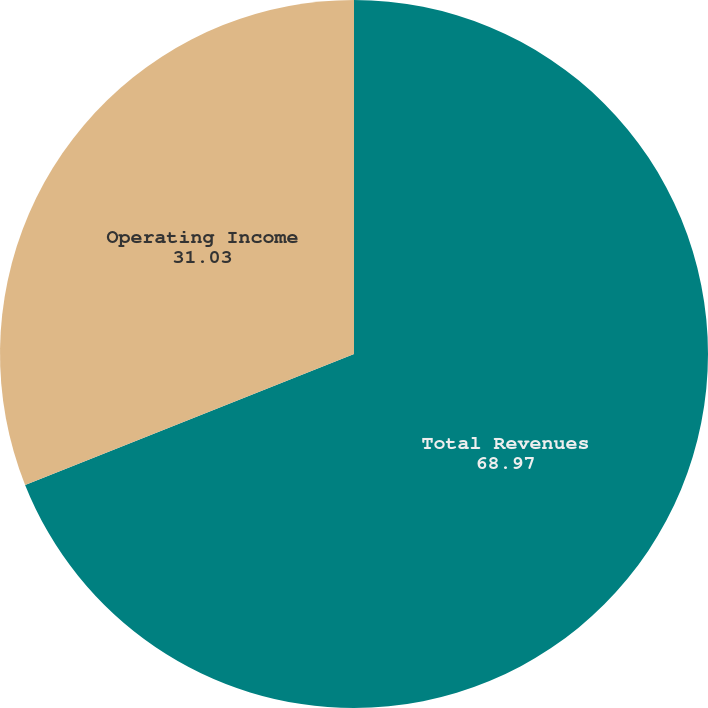<chart> <loc_0><loc_0><loc_500><loc_500><pie_chart><fcel>Total Revenues<fcel>Operating Income<nl><fcel>68.97%<fcel>31.03%<nl></chart> 